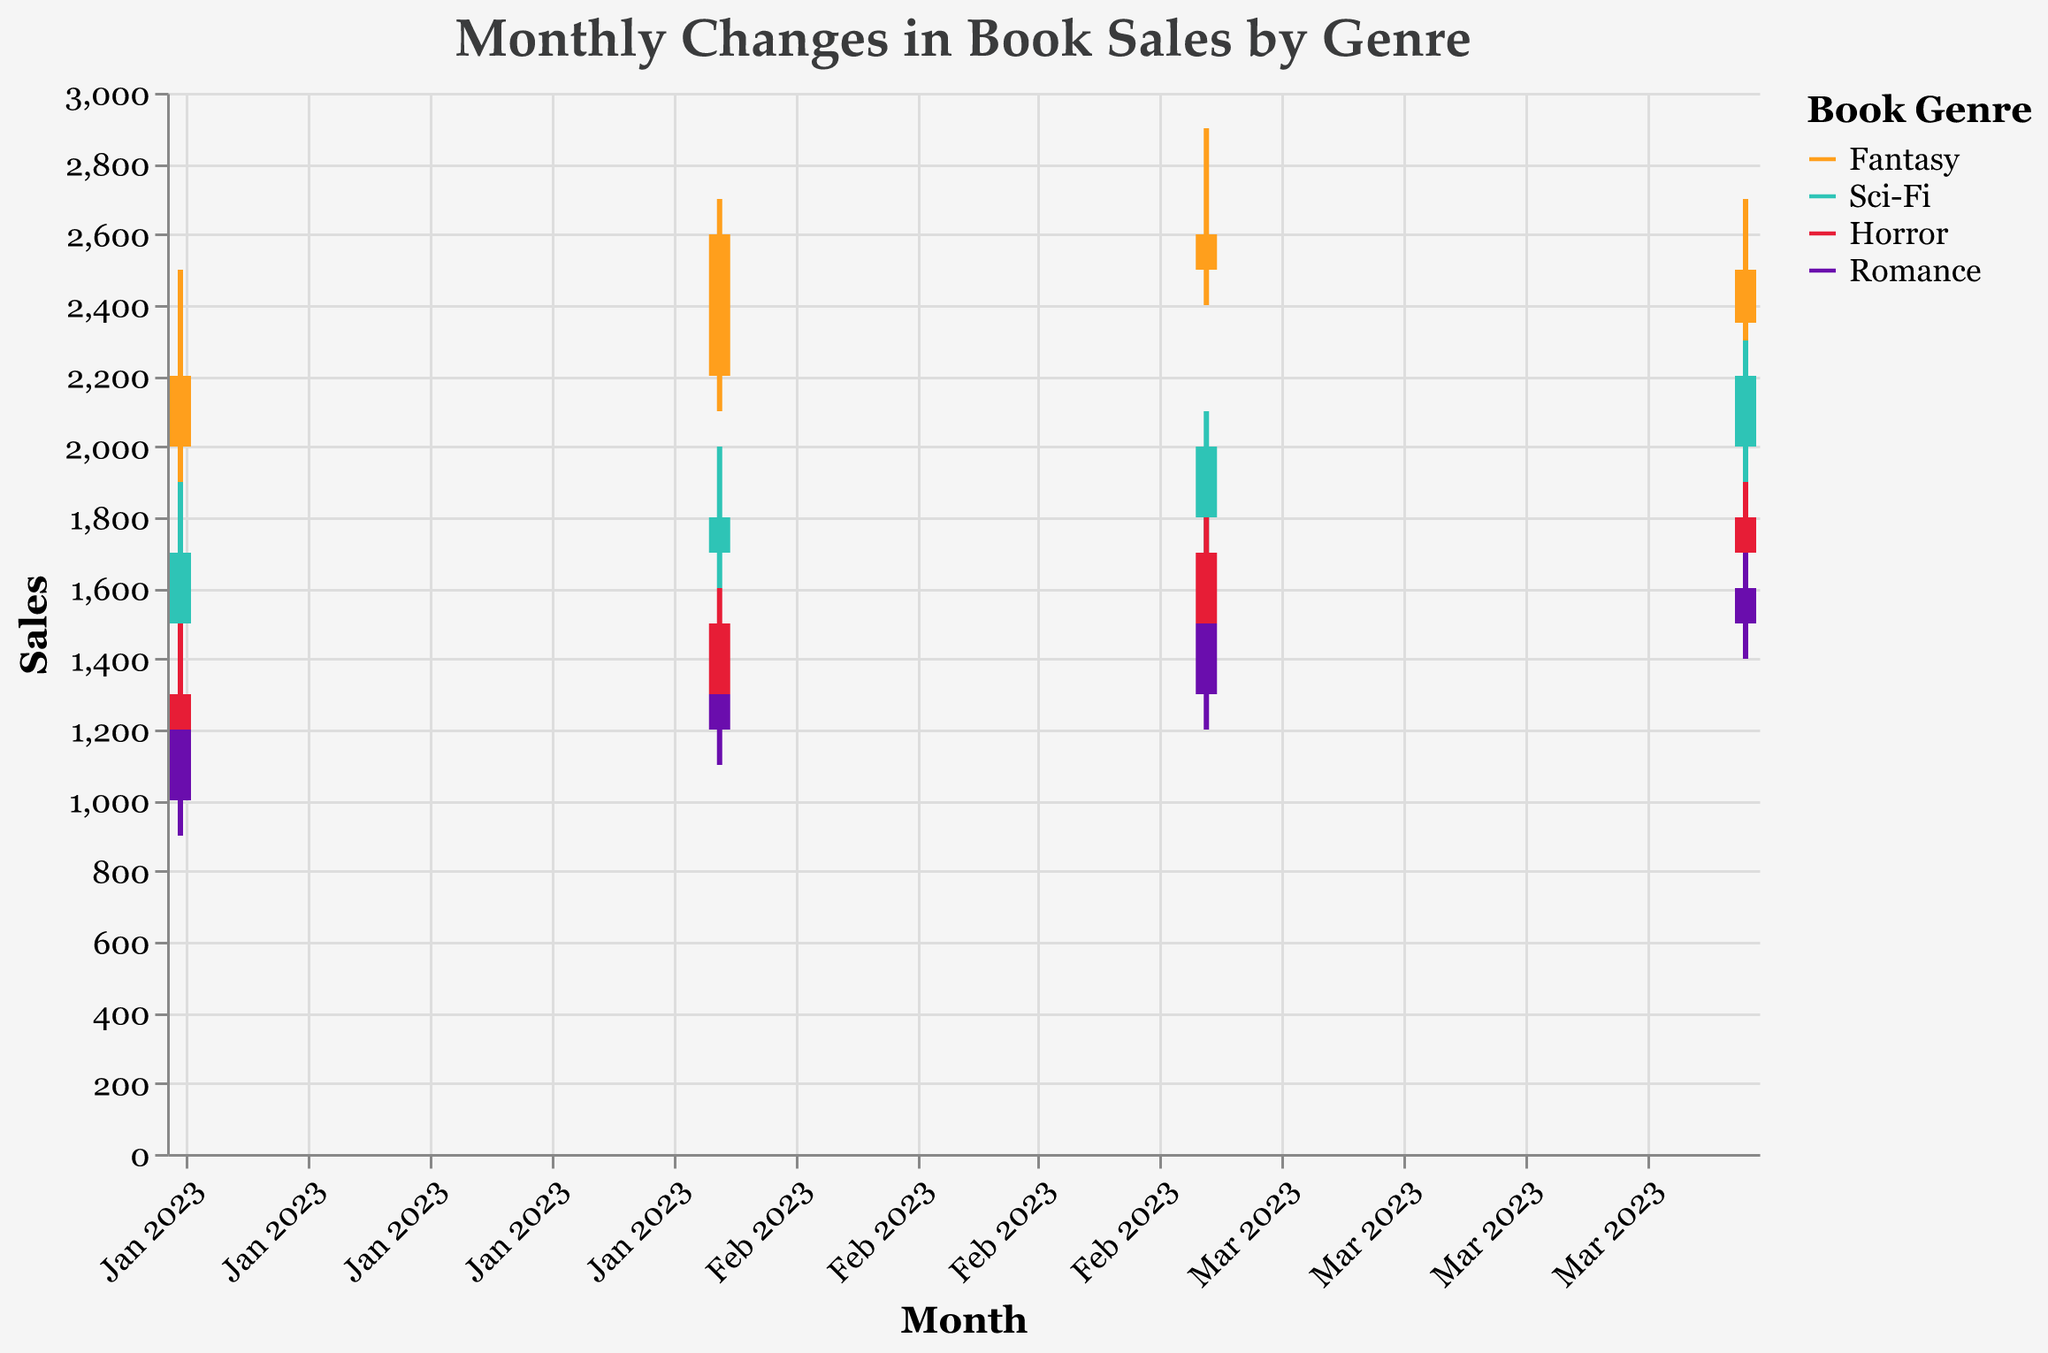What is the title of the figure? The title can be found at the top of the plot and usually describes the content of the figure. Here, the title is clearly mentioned at the top in bigger and distinct font.
Answer: Monthly Changes in Book Sales by Genre Which genre shows the highest sales in January 2023? To determine the highest sales, look for the bar that extends the highest on the vertical axis under the month labeled Jan 2023. The Fantasy genre has the highest 'Close' value of 2200.
Answer: Fantasy What is the sales difference between Fantasy and Sci-Fi genres in February 2023? First, identify the 'Close' values for both genres in February 2023. Fantasy closes at 2600 and Sci-Fi at 1800. The difference is 2600 - 1800 = 800.
Answer: 800 Which genre has the most consistent growth from January 2023 to April 2023? Examine the 'Close' value trend for each genre from January 2023 to April 2023. Horror shows a gradual and consistent increase every month: 1300, 1500, 1700, 1800.
Answer: Horror Which month shows the highest volatility for Fantasy sales and what is that volatility? Volatility can be identified by the difference between the 'High' and 'Low' values. For Fantasy, the highest volatility is in February 2023 with High = 2700 and Low = 2100, giving a volatility of 2700 - 2100 = 600.
Answer: February 2023, 600 How does the sales trend of the Romance genre compare to Horror from January to April 2023? Examine the 'Close' values and their trend for Romance (1200 → 1300 → 1500 → 1600) and Horror (1300 → 1500 → 1700 → 1800). Both show a consistent increase, but Horror ends up higher.
Answer: Similar trend but Horror ends higher What is the highest sales value recorded in the Sci-Fi genre, and in which month was it recorded? For Sci-Fi, identify the highest 'High' value in the dataset. Sci-Fi's highest value is 2300 in April 2023.
Answer: 2300, April 2023 Comparing all genres in April 2023, which one has the lowest 'Close' value, and what is that value? Look at the 'Close' values for all genres in April 2023. The lowest 'Close' value is for Fantasy, which is 2350.
Answer: Fantasy, 2350 Can you identify any month where all genres had an increase in sales compared to the previous month? For each genre, compare the 'Close' value of a month to the 'Close' value of the previous month. March 2023 has all genres increasing compared to February 2023.
Answer: March 2023 